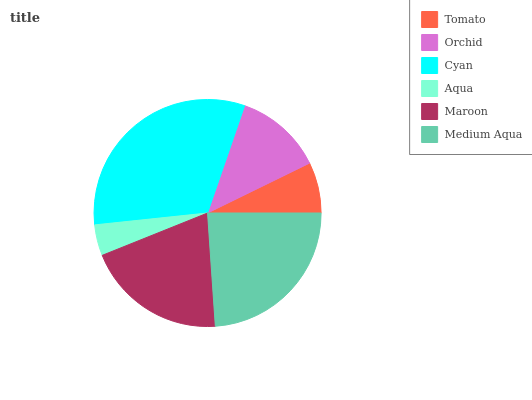Is Aqua the minimum?
Answer yes or no. Yes. Is Cyan the maximum?
Answer yes or no. Yes. Is Orchid the minimum?
Answer yes or no. No. Is Orchid the maximum?
Answer yes or no. No. Is Orchid greater than Tomato?
Answer yes or no. Yes. Is Tomato less than Orchid?
Answer yes or no. Yes. Is Tomato greater than Orchid?
Answer yes or no. No. Is Orchid less than Tomato?
Answer yes or no. No. Is Maroon the high median?
Answer yes or no. Yes. Is Orchid the low median?
Answer yes or no. Yes. Is Medium Aqua the high median?
Answer yes or no. No. Is Tomato the low median?
Answer yes or no. No. 